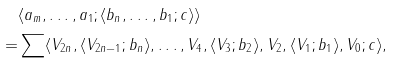Convert formula to latex. <formula><loc_0><loc_0><loc_500><loc_500>& \langle a _ { m } , \dots , a _ { 1 } ; \langle b _ { n } , \dots , b _ { 1 } ; c \rangle \rangle \\ = & \sum \langle V _ { 2 n } , \langle V _ { 2 n - 1 } ; b _ { n } \rangle , \dots , V _ { 4 } , \langle V _ { 3 } ; b _ { 2 } \rangle , V _ { 2 } , \langle V _ { 1 } ; b _ { 1 } \rangle , V _ { 0 } ; c \rangle ,</formula> 